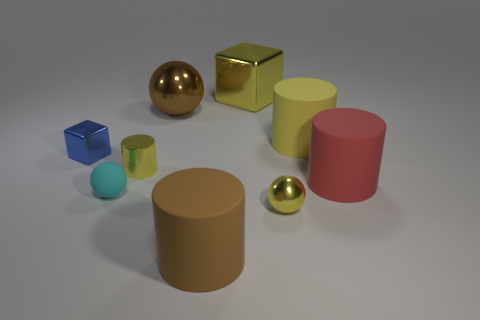What material is the big object that is the same color as the large metal sphere?
Provide a short and direct response. Rubber. There is a metal sphere that is in front of the small cyan thing; is it the same color as the small metal cylinder?
Keep it short and to the point. Yes. There is a metallic cube that is on the right side of the ball that is behind the yellow shiny cylinder; how many tiny shiny objects are in front of it?
Provide a succinct answer. 3. Is the number of big brown shiny objects that are left of the matte sphere less than the number of small purple metallic objects?
Provide a short and direct response. No. There is a large rubber object left of the small metal sphere; what shape is it?
Offer a very short reply. Cylinder. There is a brown object in front of the yellow cylinder to the right of the brown object behind the big red cylinder; what is its shape?
Provide a succinct answer. Cylinder. How many things are either large metallic things or brown matte things?
Keep it short and to the point. 3. There is a tiny yellow shiny object behind the yellow ball; is it the same shape as the tiny yellow metallic thing on the right side of the big yellow cube?
Offer a terse response. No. How many metallic things are both to the right of the cyan matte sphere and to the left of the small rubber sphere?
Ensure brevity in your answer.  0. What number of other objects are the same size as the brown matte cylinder?
Provide a short and direct response. 4. 